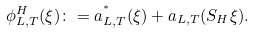<formula> <loc_0><loc_0><loc_500><loc_500>\phi _ { L , T } ^ { H } ( \xi ) \colon = a _ { L , T } ^ { ^ { * } } ( \xi ) + a _ { L , T } ( S _ { H } \xi ) .</formula> 